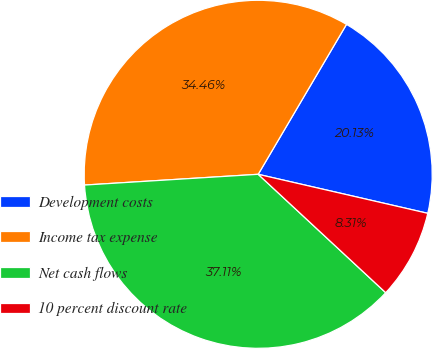Convert chart to OTSL. <chart><loc_0><loc_0><loc_500><loc_500><pie_chart><fcel>Development costs<fcel>Income tax expense<fcel>Net cash flows<fcel>10 percent discount rate<nl><fcel>20.13%<fcel>34.46%<fcel>37.11%<fcel>8.31%<nl></chart> 